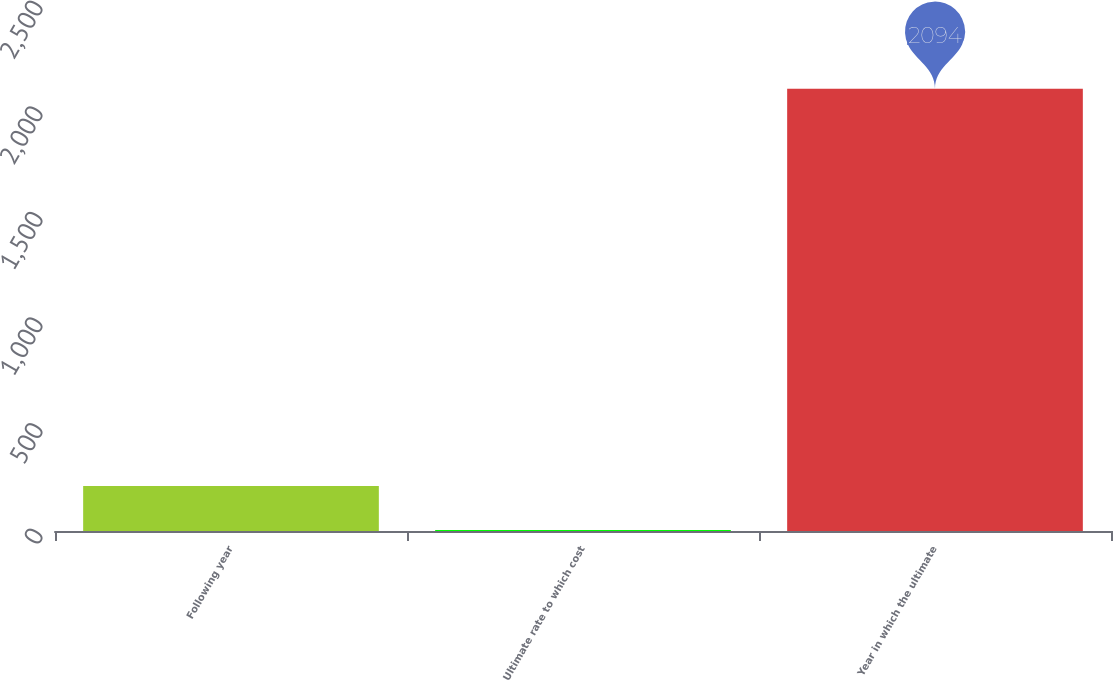Convert chart. <chart><loc_0><loc_0><loc_500><loc_500><bar_chart><fcel>Following year<fcel>Ultimate rate to which cost<fcel>Year in which the ultimate<nl><fcel>213.36<fcel>4.4<fcel>2094<nl></chart> 